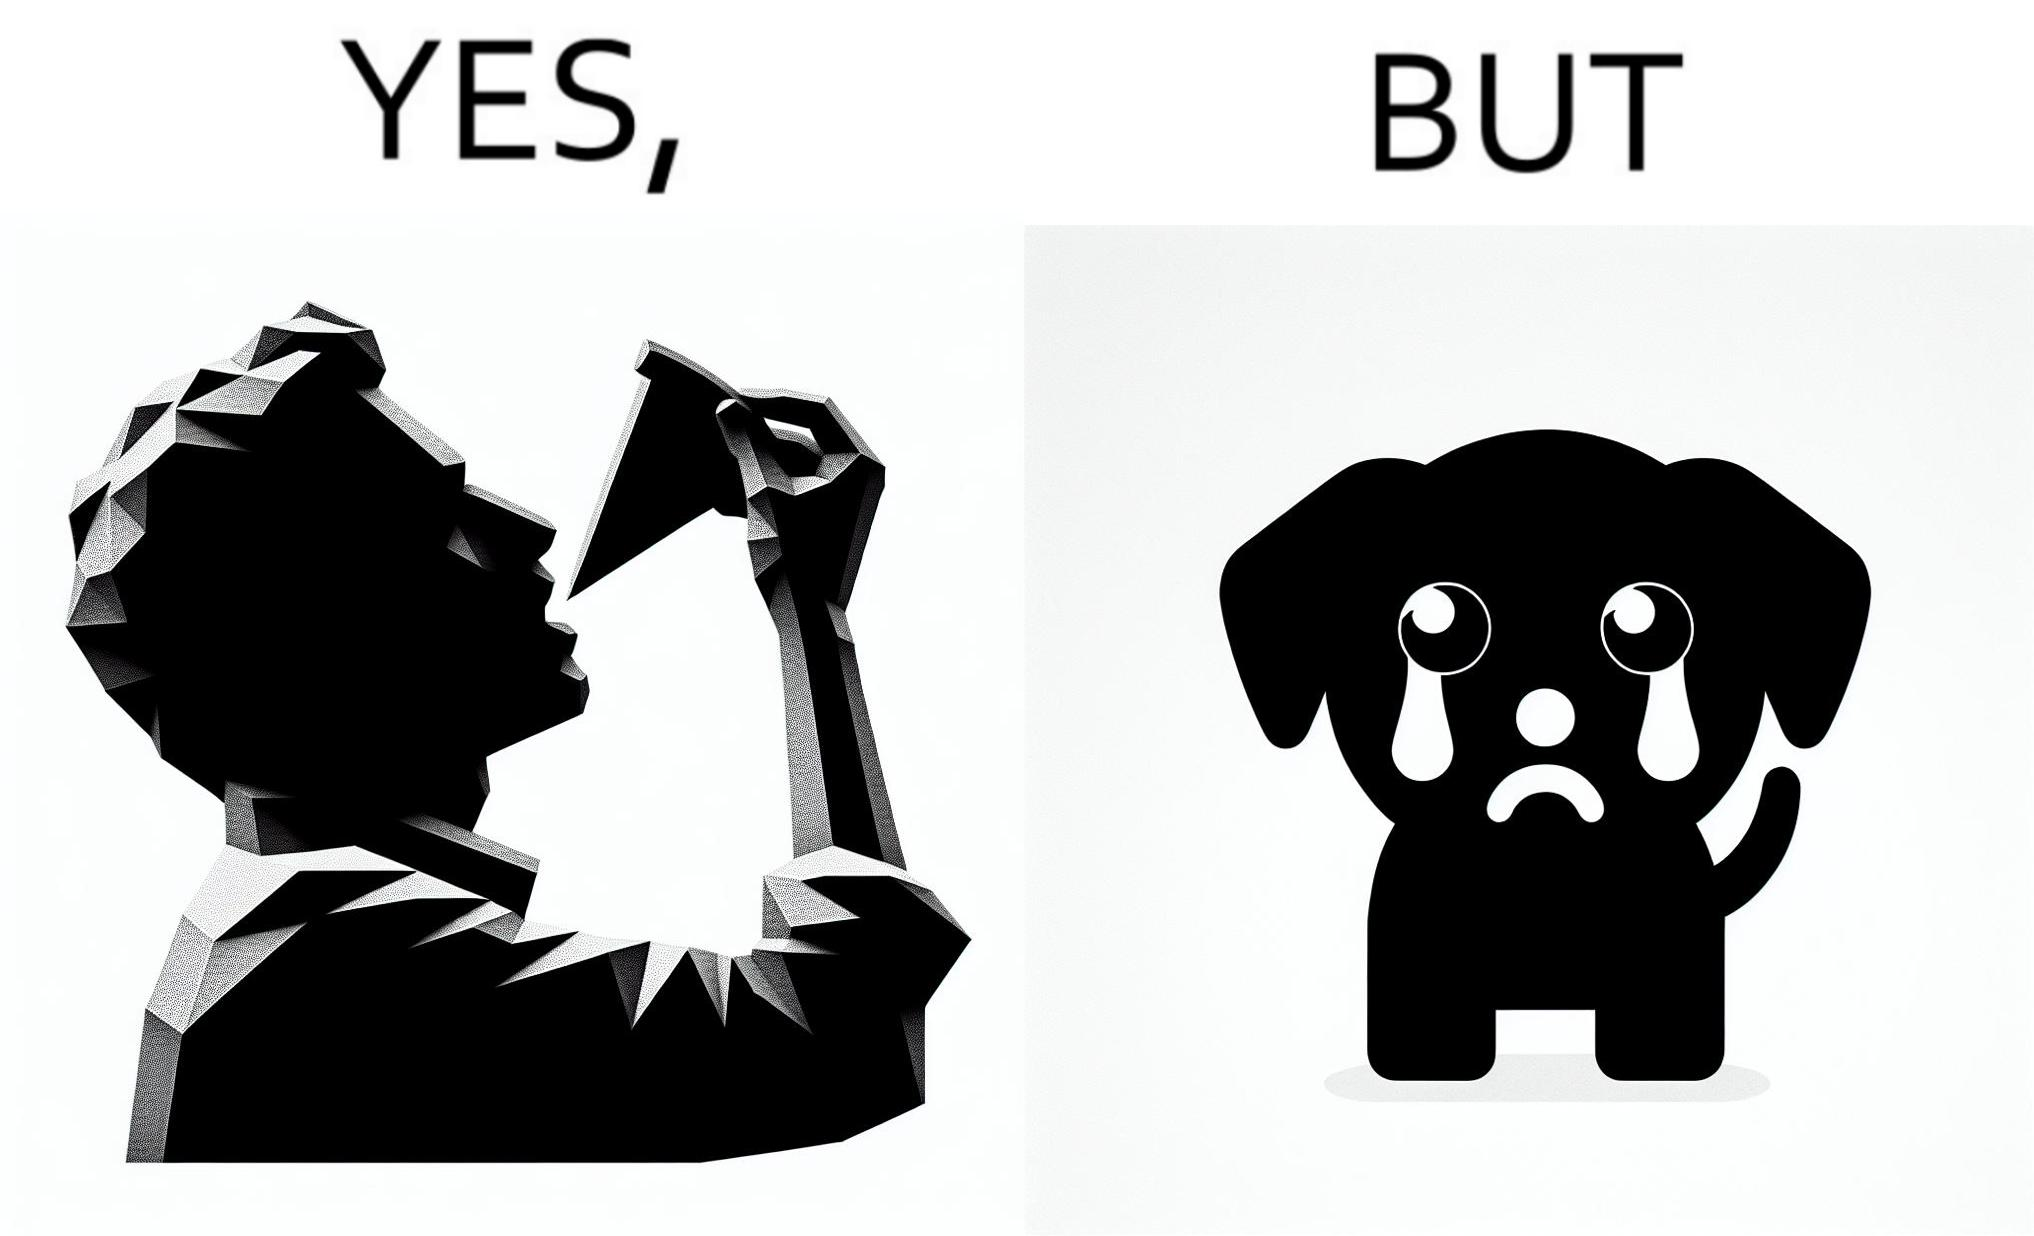Describe what you see in this image. The images are funny since they show how pet owners cannot enjoy any tasty food like pizza without sharing with their pets. The look from the pets makes the owner too guilty if he does not share his food 